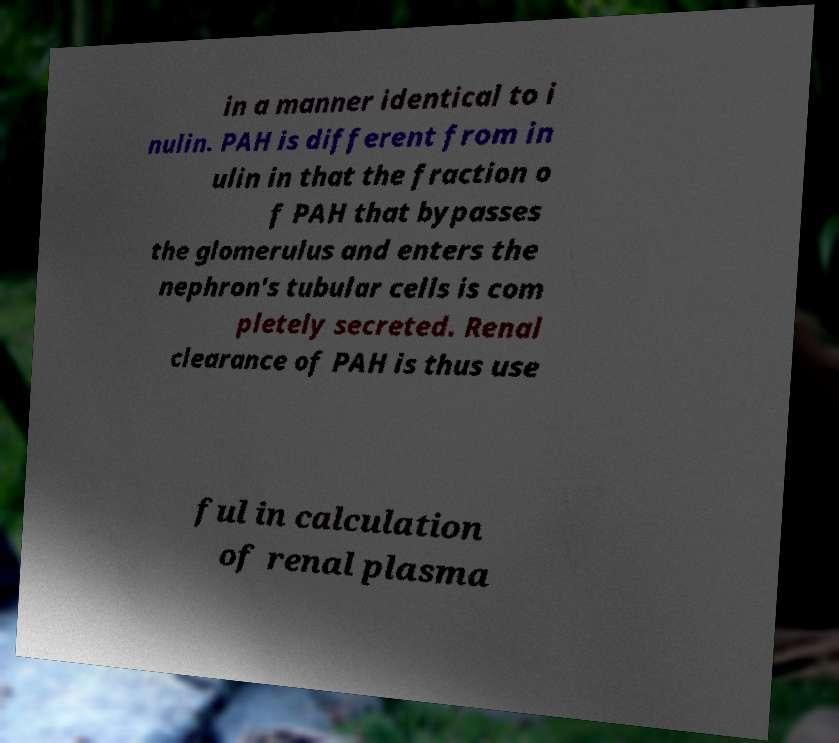I need the written content from this picture converted into text. Can you do that? in a manner identical to i nulin. PAH is different from in ulin in that the fraction o f PAH that bypasses the glomerulus and enters the nephron's tubular cells is com pletely secreted. Renal clearance of PAH is thus use ful in calculation of renal plasma 